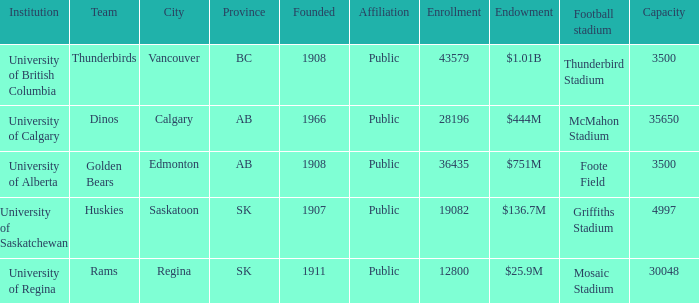What year was mcmahon stadium founded? 1966.0. Can you parse all the data within this table? {'header': ['Institution', 'Team', 'City', 'Province', 'Founded', 'Affiliation', 'Enrollment', 'Endowment', 'Football stadium', 'Capacity'], 'rows': [['University of British Columbia', 'Thunderbirds', 'Vancouver', 'BC', '1908', 'Public', '43579', '$1.01B', 'Thunderbird Stadium', '3500'], ['University of Calgary', 'Dinos', 'Calgary', 'AB', '1966', 'Public', '28196', '$444M', 'McMahon Stadium', '35650'], ['University of Alberta', 'Golden Bears', 'Edmonton', 'AB', '1908', 'Public', '36435', '$751M', 'Foote Field', '3500'], ['University of Saskatchewan', 'Huskies', 'Saskatoon', 'SK', '1907', 'Public', '19082', '$136.7M', 'Griffiths Stadium', '4997'], ['University of Regina', 'Rams', 'Regina', 'SK', '1911', 'Public', '12800', '$25.9M', 'Mosaic Stadium', '30048']]} 